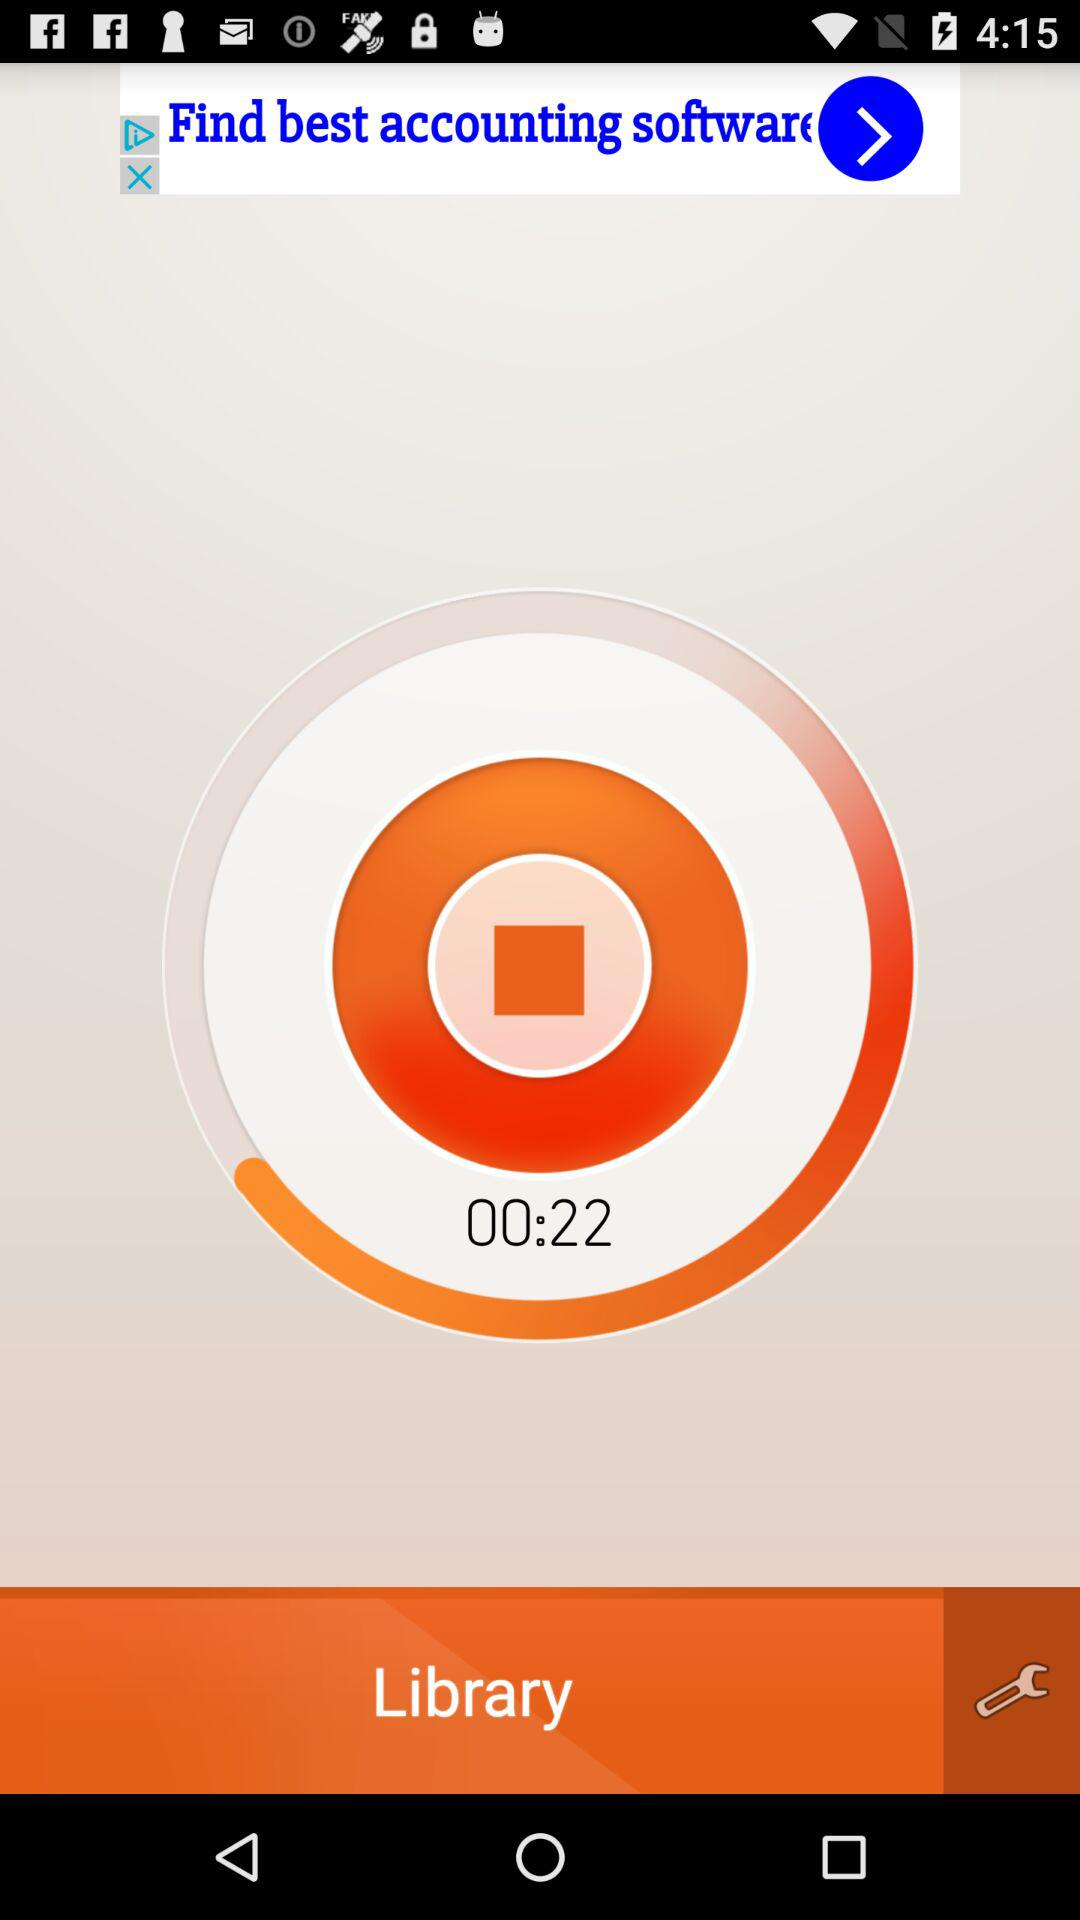What is the time duration? The time duration is 22 seconds. 